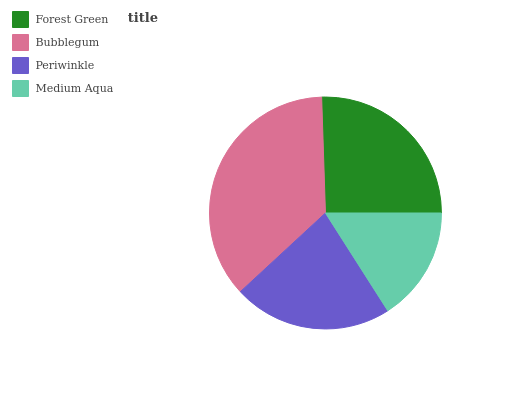Is Medium Aqua the minimum?
Answer yes or no. Yes. Is Bubblegum the maximum?
Answer yes or no. Yes. Is Periwinkle the minimum?
Answer yes or no. No. Is Periwinkle the maximum?
Answer yes or no. No. Is Bubblegum greater than Periwinkle?
Answer yes or no. Yes. Is Periwinkle less than Bubblegum?
Answer yes or no. Yes. Is Periwinkle greater than Bubblegum?
Answer yes or no. No. Is Bubblegum less than Periwinkle?
Answer yes or no. No. Is Forest Green the high median?
Answer yes or no. Yes. Is Periwinkle the low median?
Answer yes or no. Yes. Is Medium Aqua the high median?
Answer yes or no. No. Is Forest Green the low median?
Answer yes or no. No. 